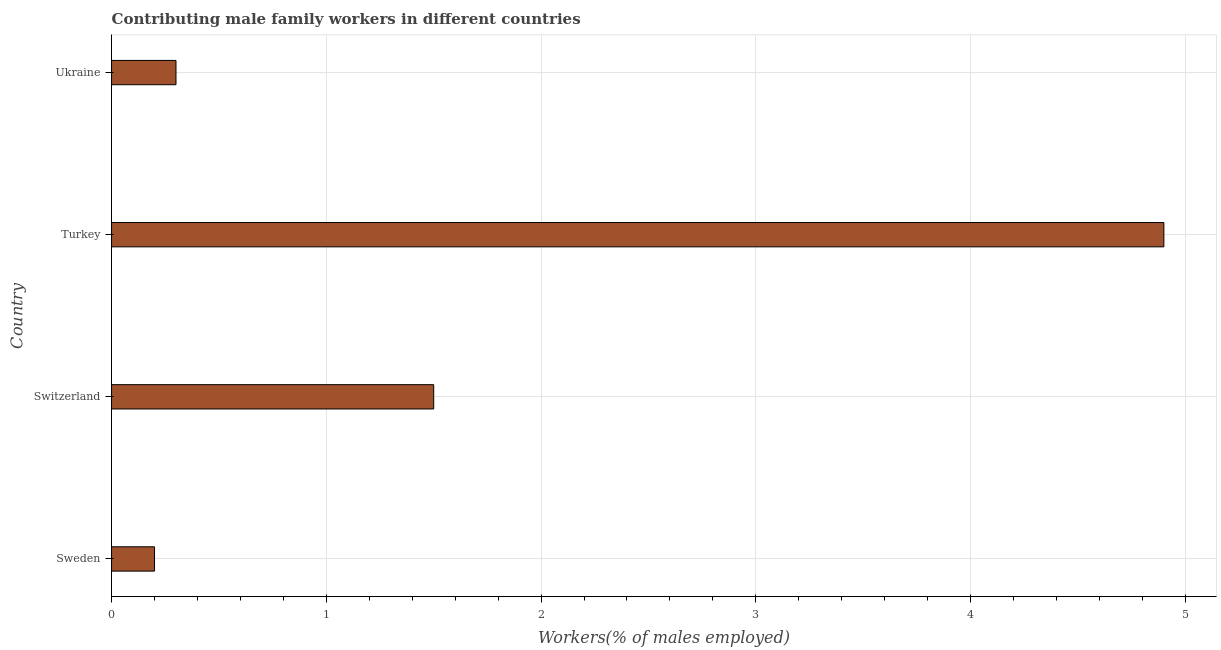Does the graph contain any zero values?
Provide a short and direct response. No. What is the title of the graph?
Offer a very short reply. Contributing male family workers in different countries. What is the label or title of the X-axis?
Your response must be concise. Workers(% of males employed). What is the contributing male family workers in Ukraine?
Provide a short and direct response. 0.3. Across all countries, what is the maximum contributing male family workers?
Offer a terse response. 4.9. Across all countries, what is the minimum contributing male family workers?
Keep it short and to the point. 0.2. In which country was the contributing male family workers minimum?
Provide a succinct answer. Sweden. What is the sum of the contributing male family workers?
Give a very brief answer. 6.9. What is the average contributing male family workers per country?
Provide a short and direct response. 1.73. What is the median contributing male family workers?
Provide a short and direct response. 0.9. In how many countries, is the contributing male family workers greater than 4.4 %?
Your response must be concise. 1. What is the ratio of the contributing male family workers in Switzerland to that in Ukraine?
Provide a short and direct response. 5. Is the difference between the contributing male family workers in Sweden and Switzerland greater than the difference between any two countries?
Your answer should be very brief. No. Is the sum of the contributing male family workers in Switzerland and Ukraine greater than the maximum contributing male family workers across all countries?
Ensure brevity in your answer.  No. In how many countries, is the contributing male family workers greater than the average contributing male family workers taken over all countries?
Give a very brief answer. 1. How many bars are there?
Provide a succinct answer. 4. Are all the bars in the graph horizontal?
Offer a very short reply. Yes. Are the values on the major ticks of X-axis written in scientific E-notation?
Your response must be concise. No. What is the Workers(% of males employed) in Sweden?
Make the answer very short. 0.2. What is the Workers(% of males employed) of Turkey?
Provide a short and direct response. 4.9. What is the Workers(% of males employed) of Ukraine?
Make the answer very short. 0.3. What is the difference between the Workers(% of males employed) in Sweden and Turkey?
Give a very brief answer. -4.7. What is the difference between the Workers(% of males employed) in Sweden and Ukraine?
Give a very brief answer. -0.1. What is the difference between the Workers(% of males employed) in Switzerland and Ukraine?
Provide a succinct answer. 1.2. What is the difference between the Workers(% of males employed) in Turkey and Ukraine?
Keep it short and to the point. 4.6. What is the ratio of the Workers(% of males employed) in Sweden to that in Switzerland?
Provide a short and direct response. 0.13. What is the ratio of the Workers(% of males employed) in Sweden to that in Turkey?
Keep it short and to the point. 0.04. What is the ratio of the Workers(% of males employed) in Sweden to that in Ukraine?
Provide a succinct answer. 0.67. What is the ratio of the Workers(% of males employed) in Switzerland to that in Turkey?
Ensure brevity in your answer.  0.31. What is the ratio of the Workers(% of males employed) in Switzerland to that in Ukraine?
Offer a terse response. 5. What is the ratio of the Workers(% of males employed) in Turkey to that in Ukraine?
Your answer should be compact. 16.33. 